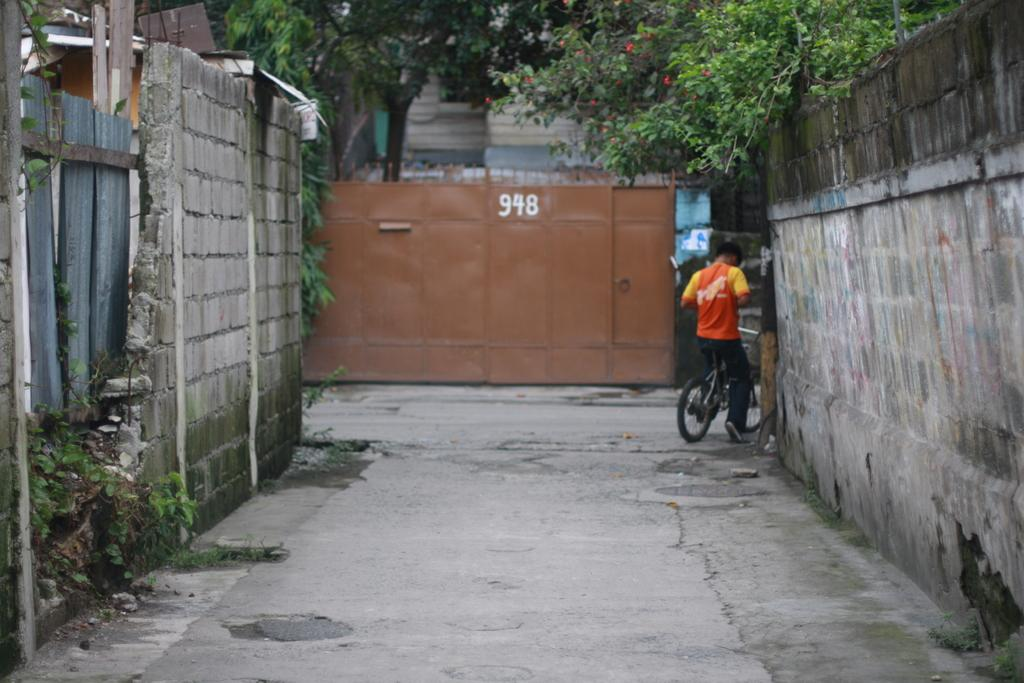<image>
Present a compact description of the photo's key features. A metal gate that says 948 on it is at the end of an alley. 